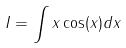<formula> <loc_0><loc_0><loc_500><loc_500>I = \int x \cos ( x ) d x</formula> 